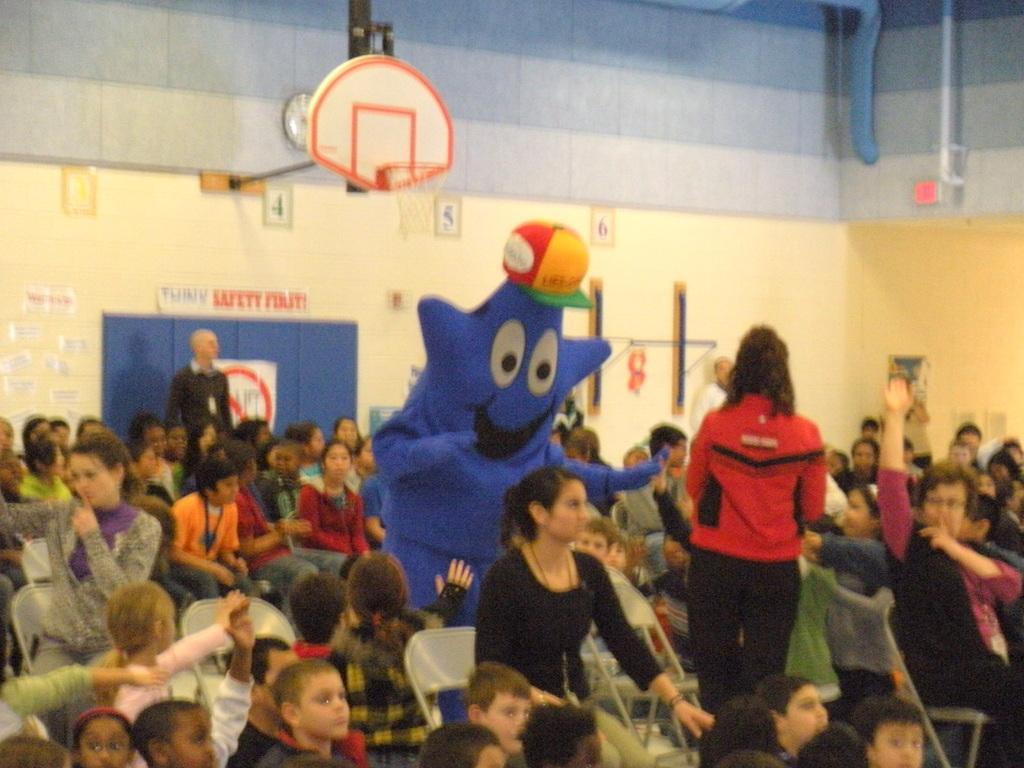Describe this image in one or two sentences. In the center of the image we can see a clown. In the background there is a wall and a door. At the bottom there are people sitting. At the top there is a clock placed on the wall and we can see pipes. 